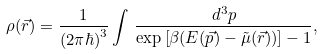Convert formula to latex. <formula><loc_0><loc_0><loc_500><loc_500>\rho ( \vec { r } ) = \frac { 1 } { ( 2 \pi \hbar { ) } ^ { 3 } } \int \, \frac { d ^ { 3 } p } { \exp \left [ \beta ( E ( \vec { p } ) - \tilde { \mu } ( \vec { r } ) ) \right ] - 1 } ,</formula> 